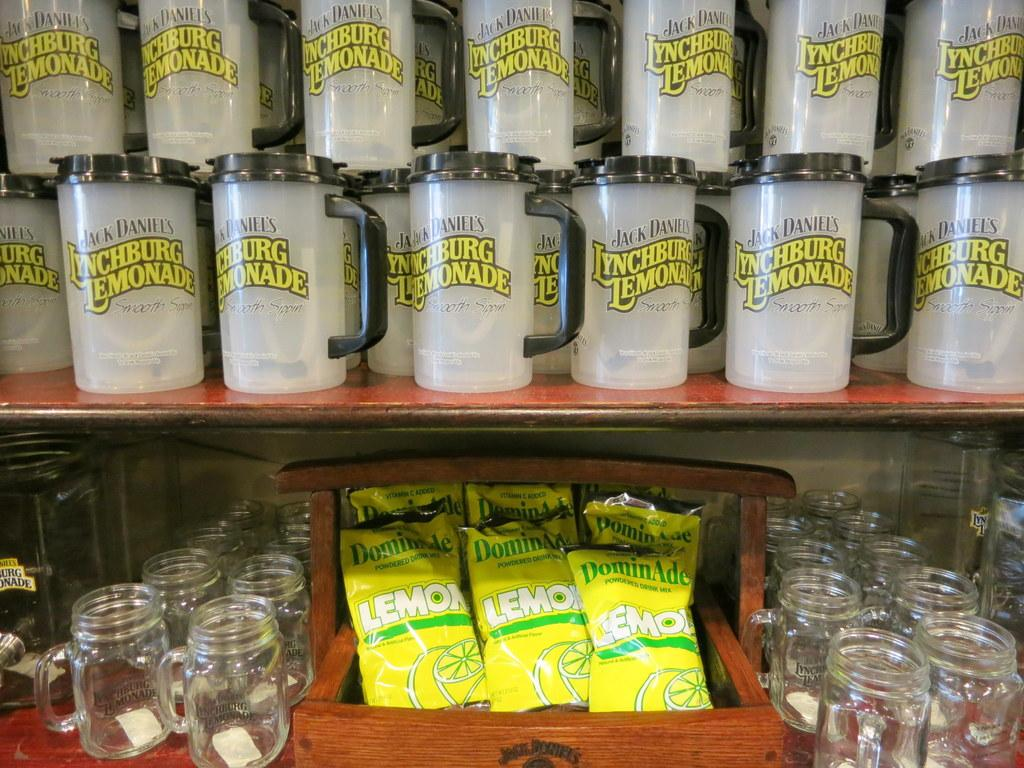Provide a one-sentence caption for the provided image. A variety of merchandise bearing the Lynchburg lemonade brand is arranged in two rows with cups on top and glasses on the bottom. 